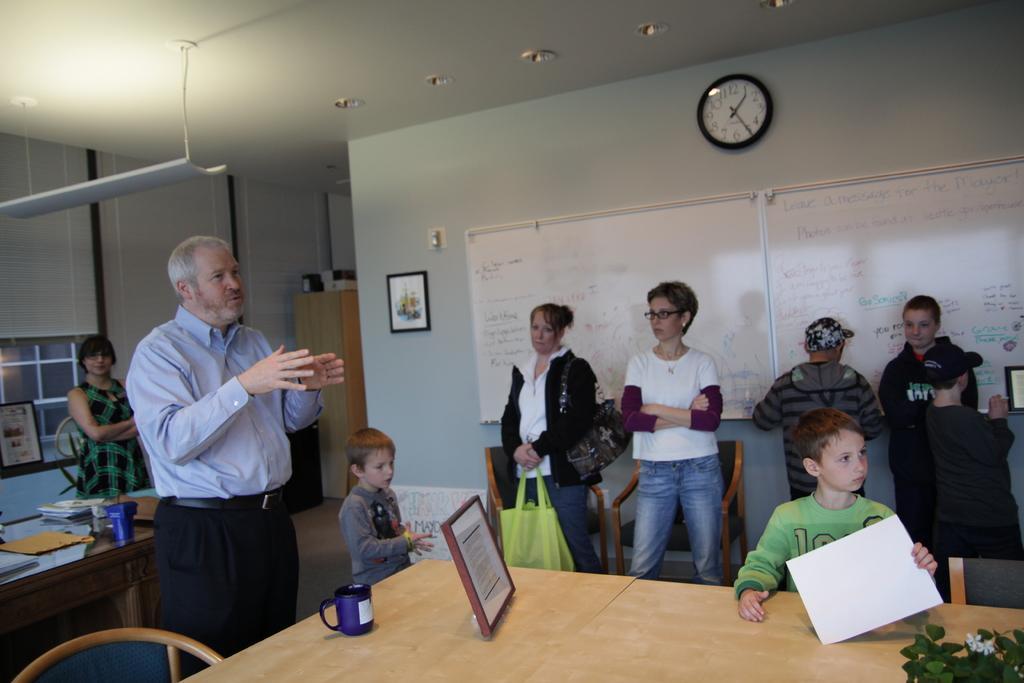Could you give a brief overview of what you see in this image? In this image i can see few persons standing there is a frame, a glass, a tree on a table at the back ground i can see a board, a clock, a frame to a wall. 